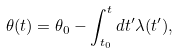<formula> <loc_0><loc_0><loc_500><loc_500>\theta ( t ) = \theta _ { 0 } - \int _ { t _ { 0 } } ^ { t } d t ^ { \prime } \lambda ( t ^ { \prime } ) ,</formula> 